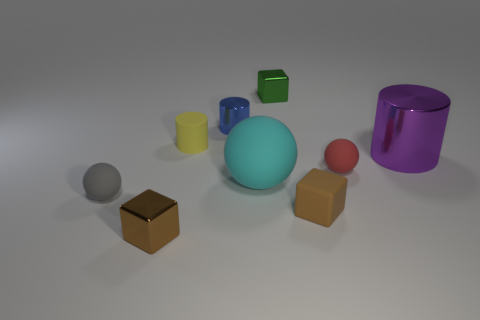The thing that is both behind the small red matte ball and left of the tiny blue shiny cylinder has what shape?
Ensure brevity in your answer.  Cylinder. What number of other things are the same color as the tiny matte block?
Your response must be concise. 1. How many things are either tiny matte things in front of the purple shiny cylinder or small blue shiny cylinders?
Offer a terse response. 4. There is a large matte thing; does it have the same color as the small cube that is behind the large purple shiny cylinder?
Your response must be concise. No. Are there any other things that have the same size as the rubber block?
Ensure brevity in your answer.  Yes. What size is the brown block in front of the brown object that is on the right side of the tiny yellow rubber object?
Provide a short and direct response. Small. How many things are either tiny objects or tiny green things behind the large cylinder?
Make the answer very short. 7. Is the shape of the tiny brown thing right of the yellow matte object the same as  the large cyan thing?
Your response must be concise. No. There is a large purple cylinder that is in front of the tiny metal block that is behind the tiny yellow rubber object; how many big metal cylinders are on the left side of it?
Ensure brevity in your answer.  0. Is there anything else that is the same shape as the small green thing?
Offer a very short reply. Yes. 